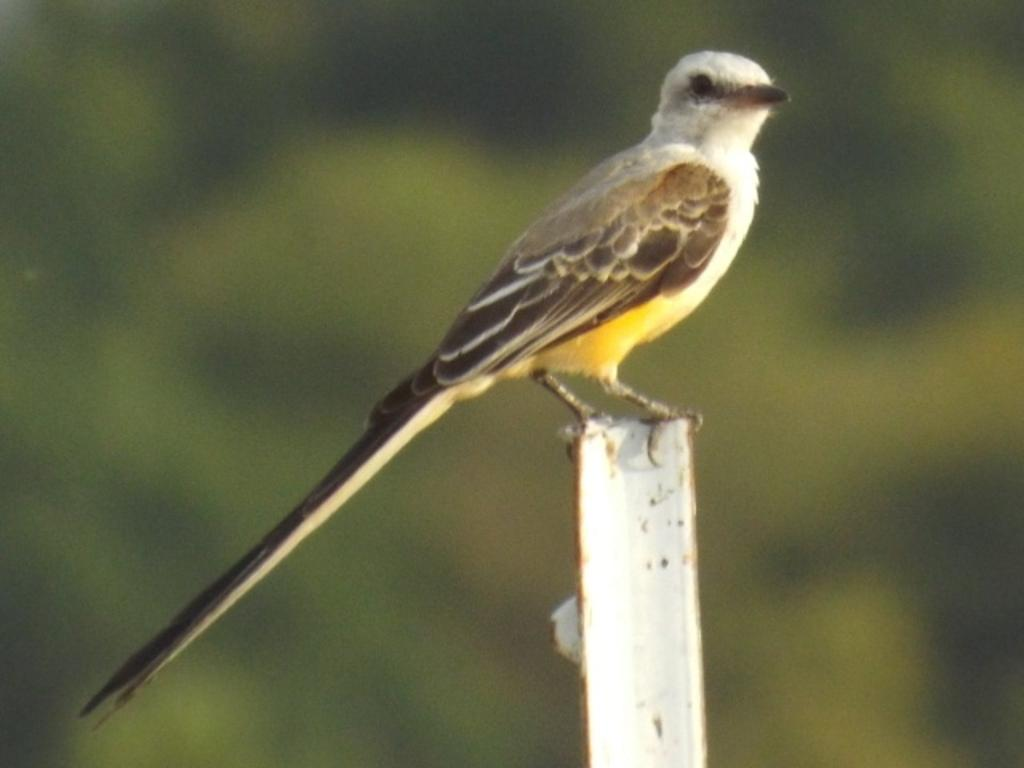What type of animal can be seen in the image? There is a small bird in the image. Where is the bird located? The bird is sitting on an iron rod. Can you describe the background of the image? The background of the image is blurred. Can you see a stream in the background of the image? There is no stream visible in the background of the image. Is there a goose present in the image? There is no goose present in the image; it features a small bird. 